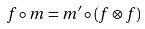Convert formula to latex. <formula><loc_0><loc_0><loc_500><loc_500>f \circ m = m ^ { \prime } \circ ( f \otimes f )</formula> 